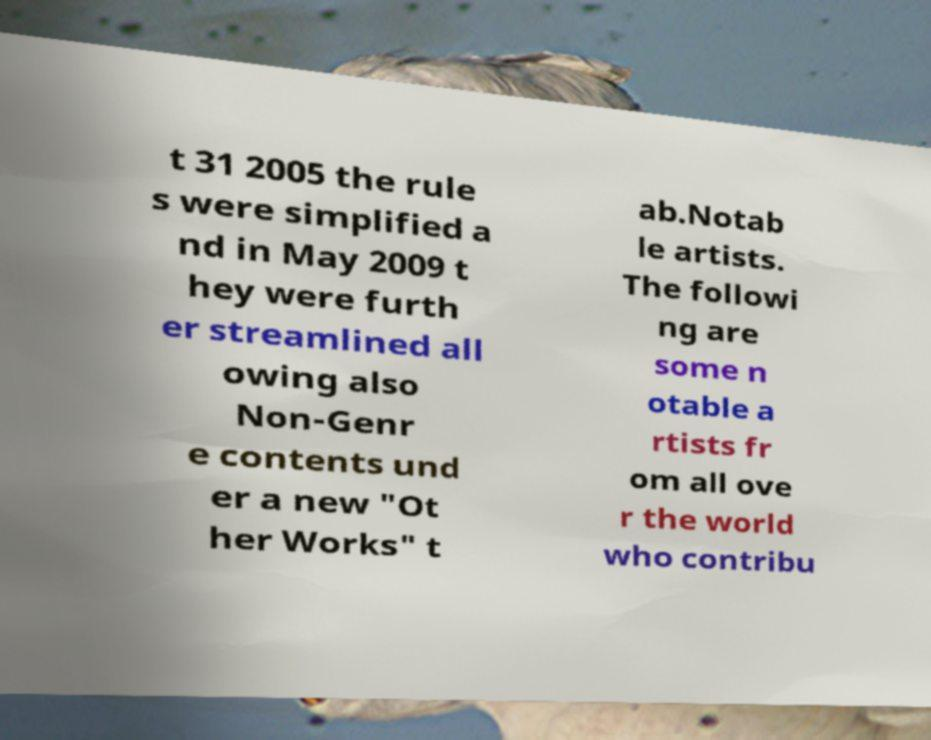Can you accurately transcribe the text from the provided image for me? t 31 2005 the rule s were simplified a nd in May 2009 t hey were furth er streamlined all owing also Non-Genr e contents und er a new "Ot her Works" t ab.Notab le artists. The followi ng are some n otable a rtists fr om all ove r the world who contribu 